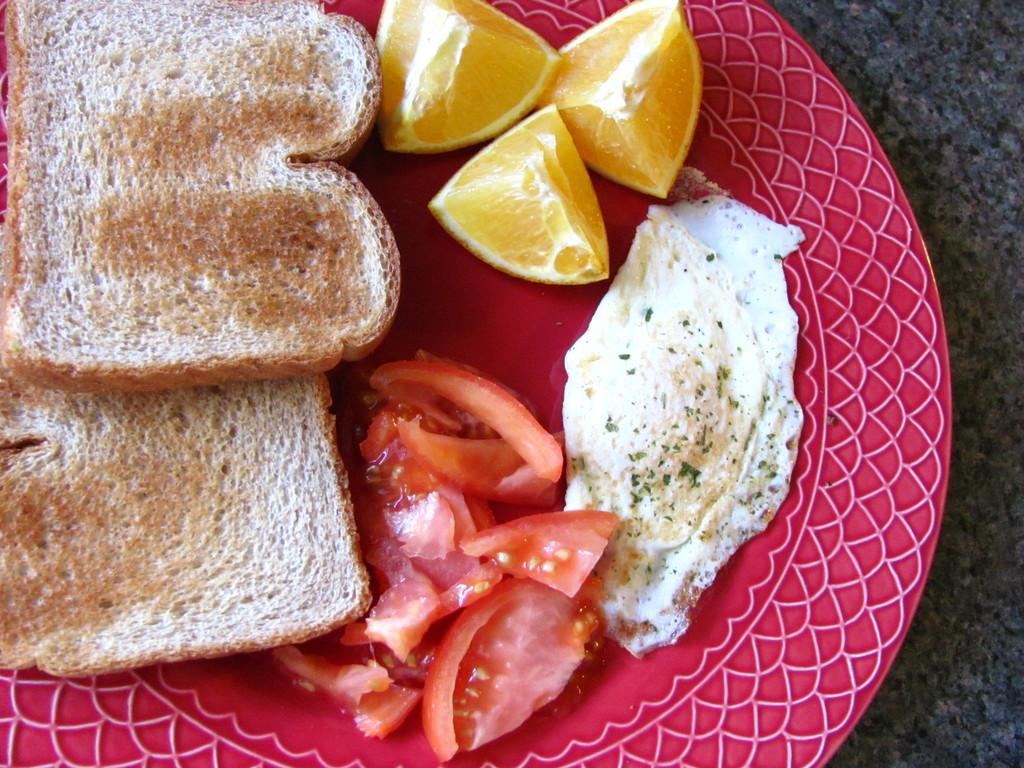What is present on the plate in the image? There are two bread slices, fruit slices, and tomato slices on the plate in the image. How many types of food can be seen on the plate? There are three types of food on the plate: bread, fruit, and tomato. Can you describe the fruit slices on the plate? The fruit slices on the plate are not specified, but they are present alongside the bread and tomato slices. How many seeds can be seen on the plate in the image? There is no information about seeds on the plate in the image. 